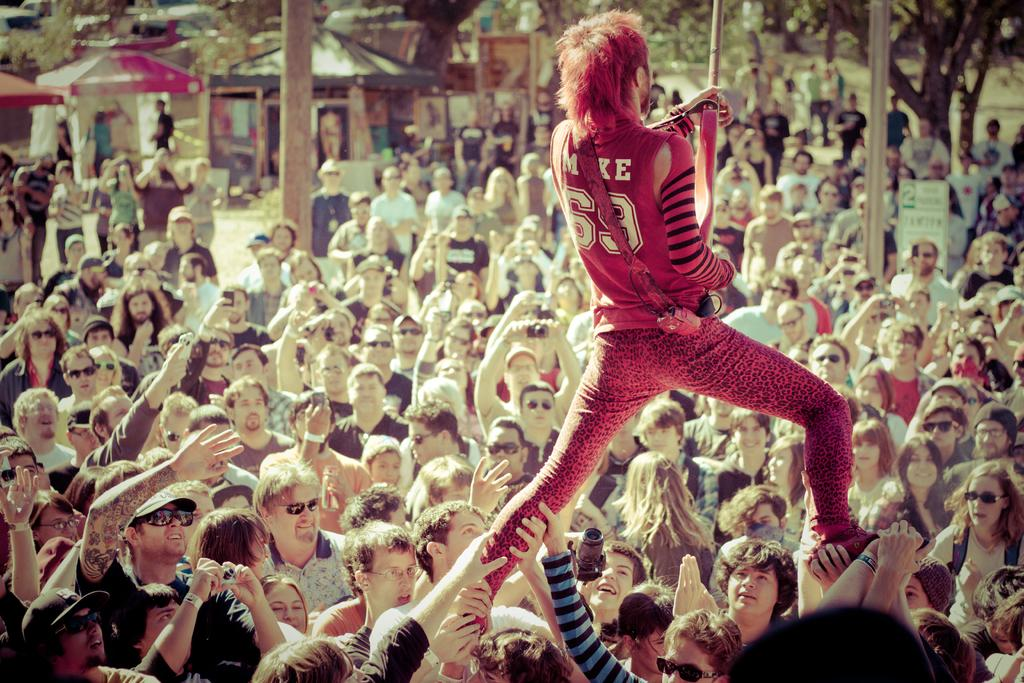How many people are in the image? There is a group of people in the image. What are some people doing in the image? Some people are holding the legs of a person. What can be seen in the background of the image? There are tents and trees in the background of the image, as well as other objects. What type of vegetable is being used as a prop in the image? There is no vegetable present in the image; it features a group of people with some holding the legs of a person, and a background with tents, trees, and other objects. 